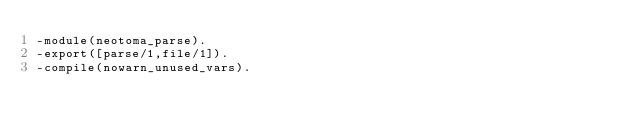Convert code to text. <code><loc_0><loc_0><loc_500><loc_500><_Erlang_>-module(neotoma_parse).
-export([parse/1,file/1]).
-compile(nowarn_unused_vars).</code> 